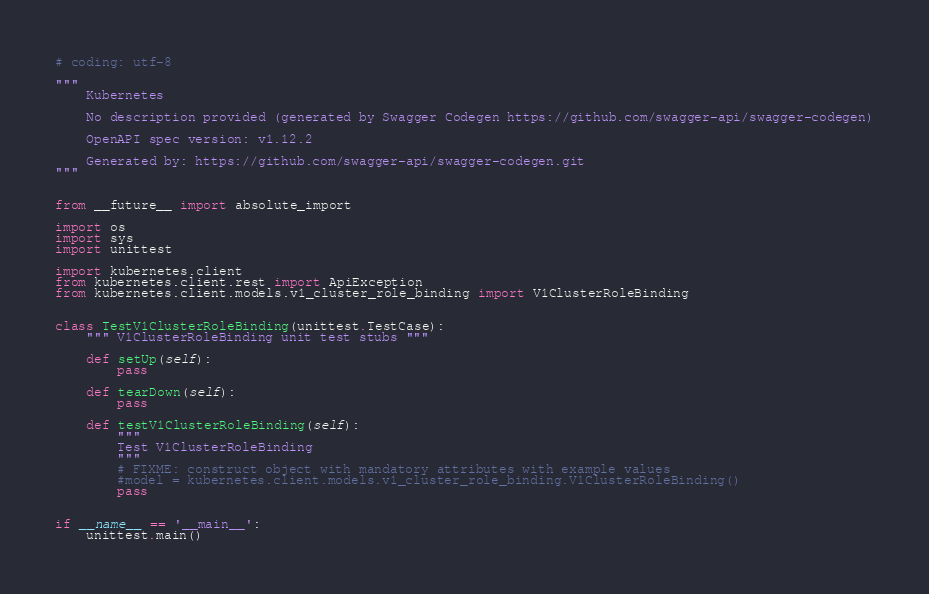Convert code to text. <code><loc_0><loc_0><loc_500><loc_500><_Python_># coding: utf-8

"""
    Kubernetes

    No description provided (generated by Swagger Codegen https://github.com/swagger-api/swagger-codegen)

    OpenAPI spec version: v1.12.2
    
    Generated by: https://github.com/swagger-api/swagger-codegen.git
"""


from __future__ import absolute_import

import os
import sys
import unittest

import kubernetes.client
from kubernetes.client.rest import ApiException
from kubernetes.client.models.v1_cluster_role_binding import V1ClusterRoleBinding


class TestV1ClusterRoleBinding(unittest.TestCase):
    """ V1ClusterRoleBinding unit test stubs """

    def setUp(self):
        pass

    def tearDown(self):
        pass

    def testV1ClusterRoleBinding(self):
        """
        Test V1ClusterRoleBinding
        """
        # FIXME: construct object with mandatory attributes with example values
        #model = kubernetes.client.models.v1_cluster_role_binding.V1ClusterRoleBinding()
        pass


if __name__ == '__main__':
    unittest.main()
</code> 